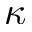Convert formula to latex. <formula><loc_0><loc_0><loc_500><loc_500>\kappa</formula> 